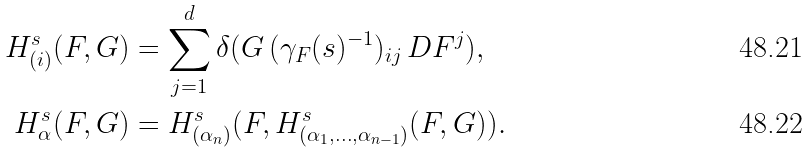<formula> <loc_0><loc_0><loc_500><loc_500>H ^ { s } _ { ( i ) } ( F , G ) & = \sum _ { j = 1 } ^ { d } \delta ( G \, ( \gamma _ { F } ( s ) ^ { - 1 } ) _ { i j } \, D F ^ { j } ) , \\ H ^ { s } _ { \alpha } ( F , G ) & = H ^ { s } _ { ( \alpha _ { n } ) } ( F , H ^ { s } _ { ( \alpha _ { 1 } , \dots , \alpha _ { n - 1 } ) } ( F , G ) ) .</formula> 